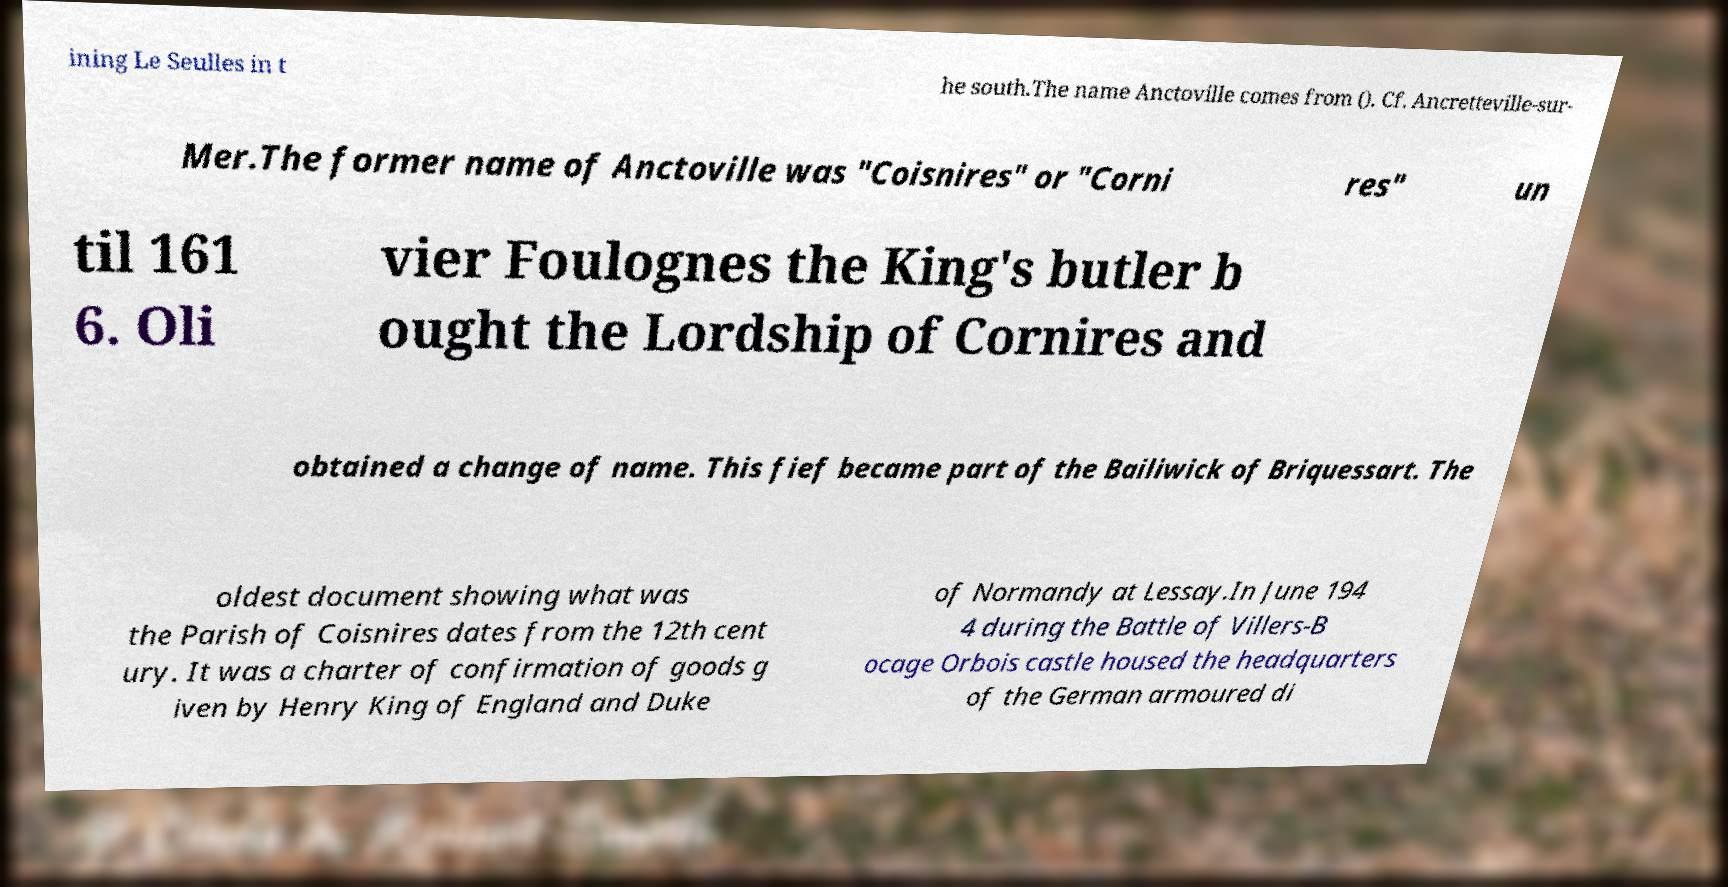For documentation purposes, I need the text within this image transcribed. Could you provide that? ining Le Seulles in t he south.The name Anctoville comes from (). Cf. Ancretteville-sur- Mer.The former name of Anctoville was "Coisnires" or "Corni res" un til 161 6. Oli vier Foulognes the King's butler b ought the Lordship of Cornires and obtained a change of name. This fief became part of the Bailiwick of Briquessart. The oldest document showing what was the Parish of Coisnires dates from the 12th cent ury. It was a charter of confirmation of goods g iven by Henry King of England and Duke of Normandy at Lessay.In June 194 4 during the Battle of Villers-B ocage Orbois castle housed the headquarters of the German armoured di 